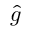<formula> <loc_0><loc_0><loc_500><loc_500>\hat { g }</formula> 